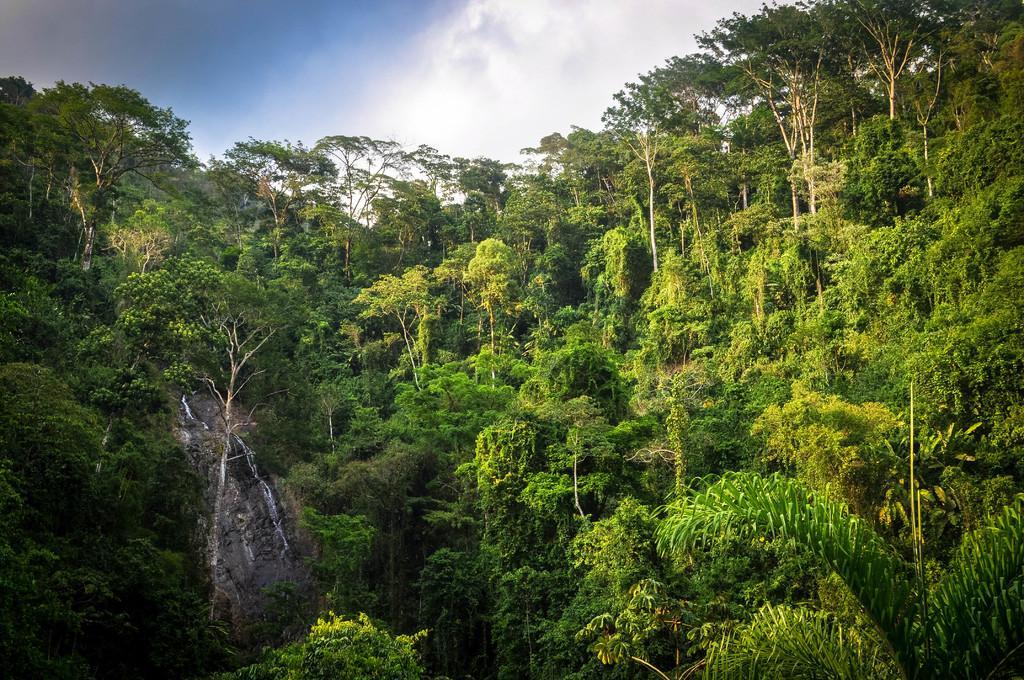Can you describe this image briefly? As we can see in the image there are trees, water, sky and clouds. 